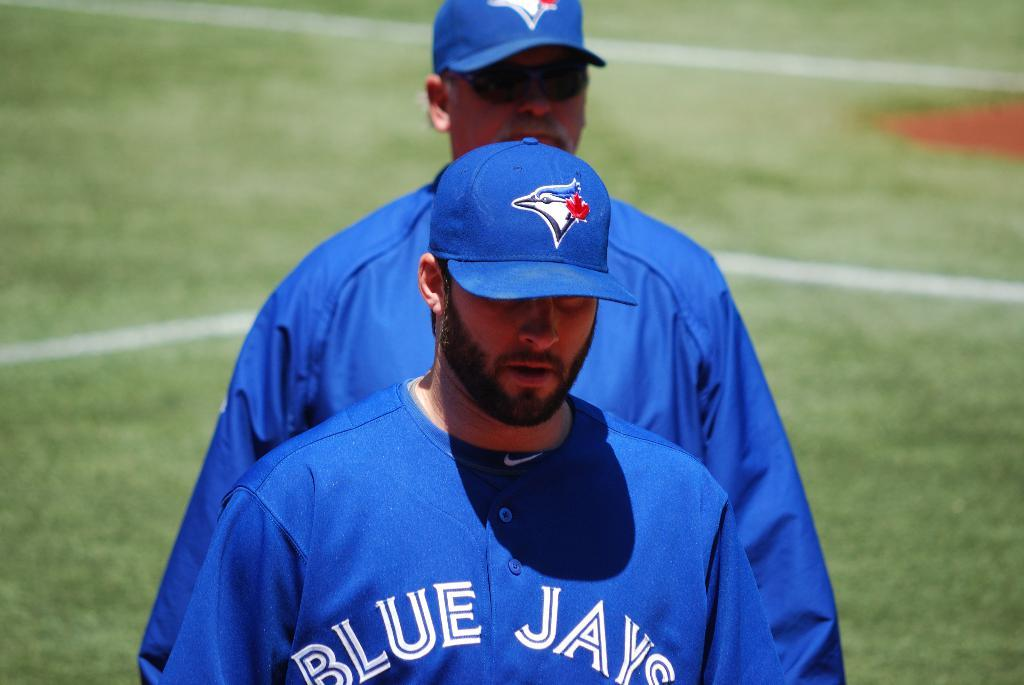Provide a one-sentence caption for the provided image. Man wearing a blue Blue Jays jersey out on the grass. 